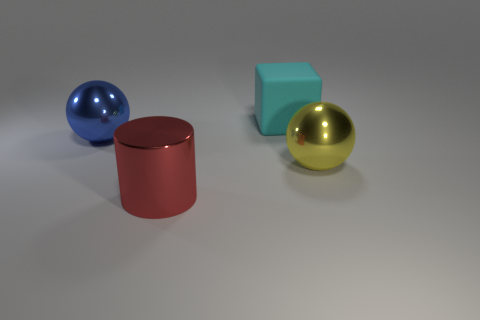What material is the big yellow thing?
Make the answer very short. Metal. There is a sphere that is behind the large sphere that is in front of the metallic ball behind the big yellow metallic ball; what is it made of?
Provide a succinct answer. Metal. Is there any other thing that is the same material as the red thing?
Give a very brief answer. Yes. There is a rubber object; is its size the same as the metal ball on the right side of the big block?
Provide a short and direct response. Yes. What number of objects are either big things that are behind the red metal cylinder or blue shiny things to the left of the big red shiny cylinder?
Make the answer very short. 3. What is the color of the big ball that is on the left side of the cyan object?
Provide a succinct answer. Blue. Are there any large blue metallic balls that are in front of the metallic ball in front of the big blue shiny sphere?
Keep it short and to the point. No. Is the number of cyan matte cubes less than the number of large yellow matte spheres?
Provide a short and direct response. No. What is the material of the sphere right of the sphere that is to the left of the red metal object?
Keep it short and to the point. Metal. Is the red metal thing the same size as the rubber thing?
Ensure brevity in your answer.  Yes. 